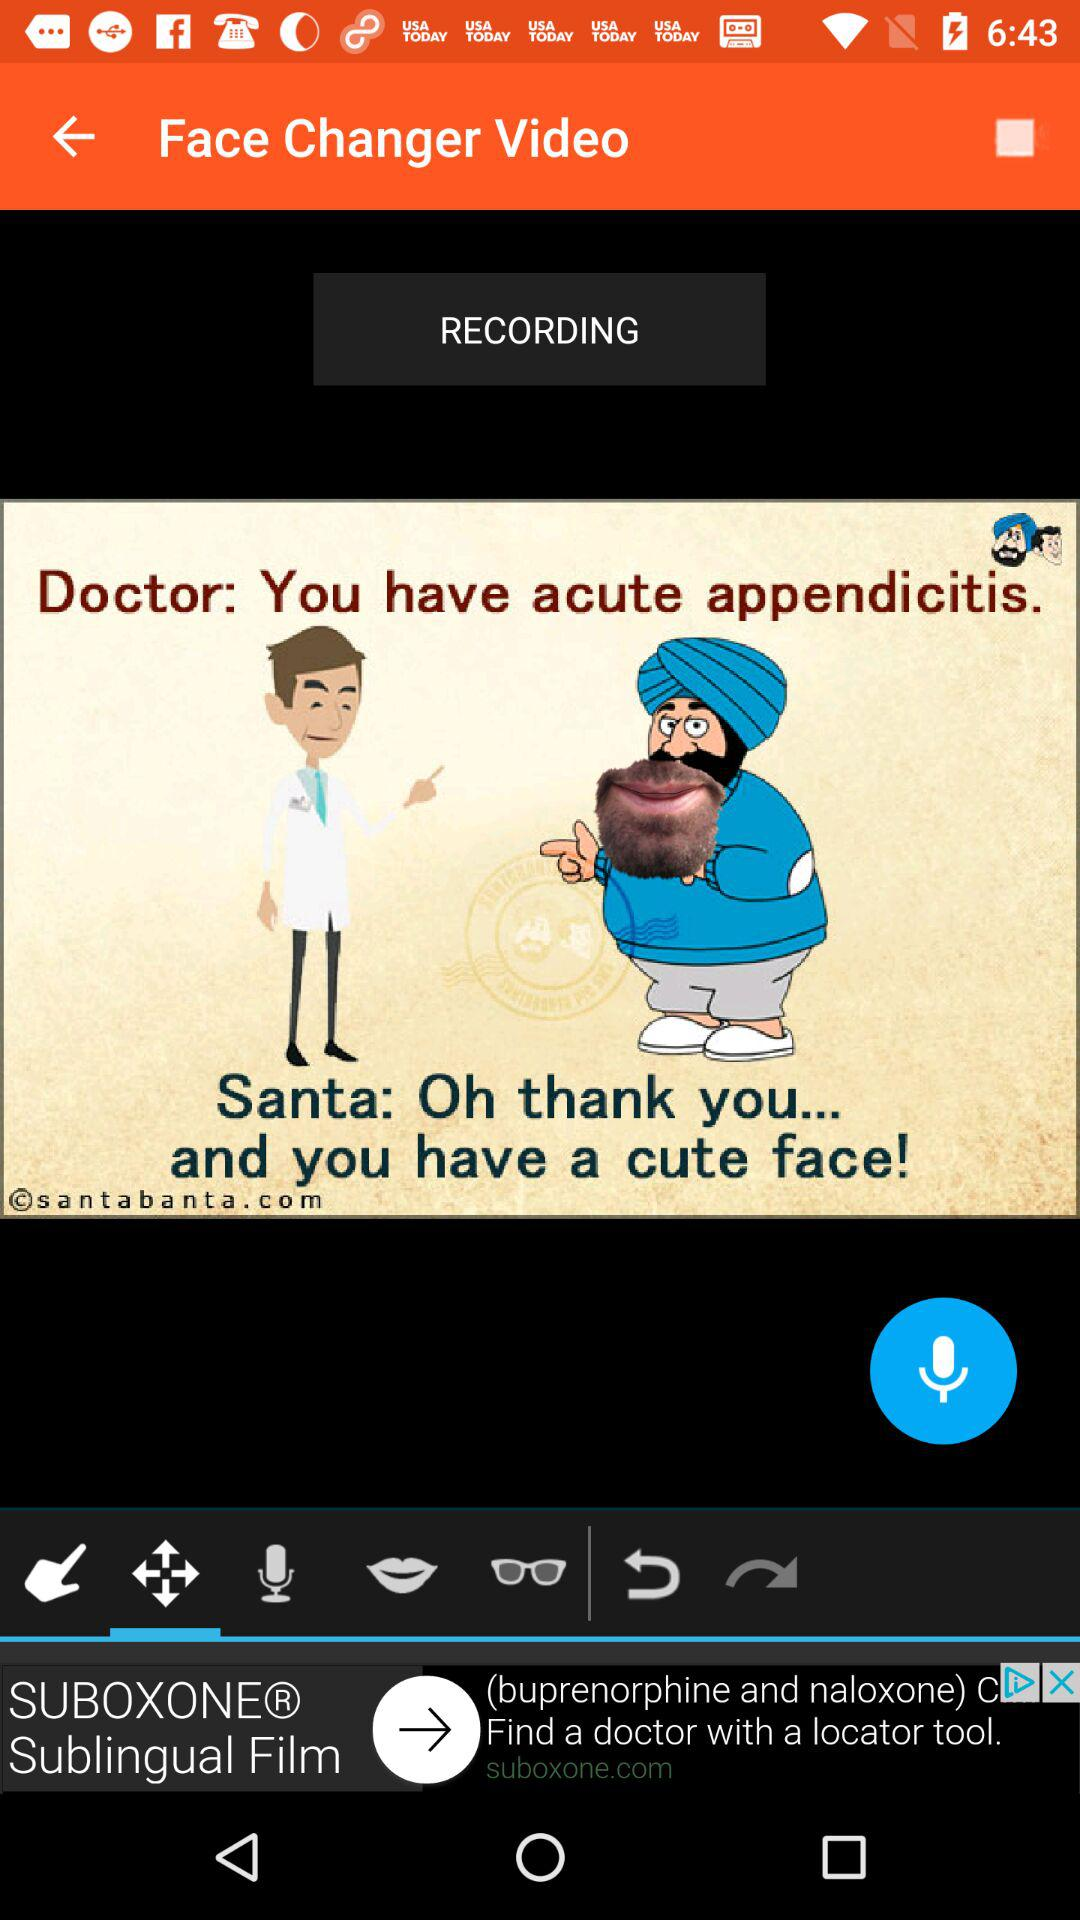What is the name of the application? The application name is "Face Changer Video". 